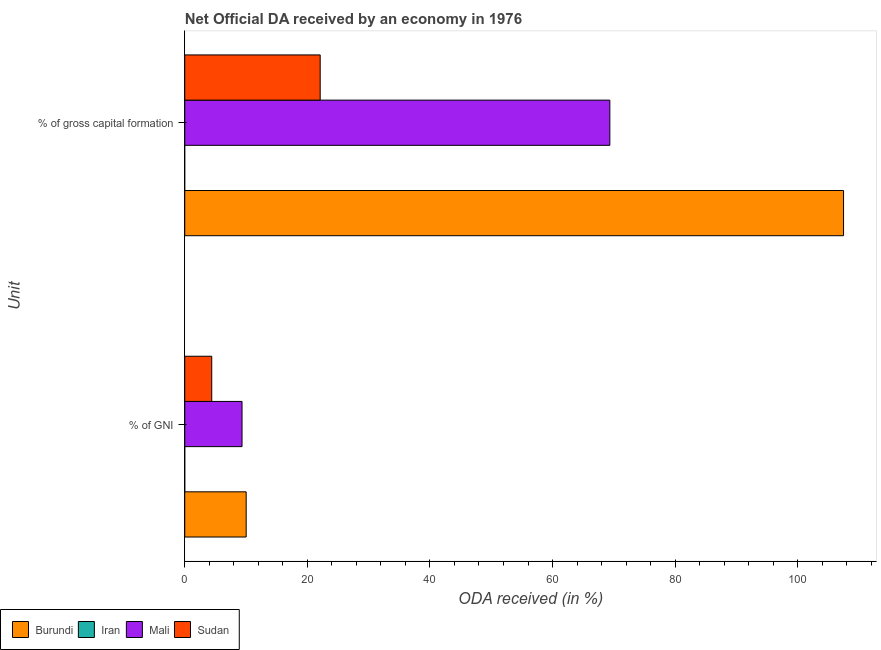How many different coloured bars are there?
Your response must be concise. 3. Are the number of bars on each tick of the Y-axis equal?
Offer a very short reply. Yes. How many bars are there on the 2nd tick from the top?
Offer a terse response. 3. What is the label of the 1st group of bars from the top?
Offer a very short reply. % of gross capital formation. What is the oda received as percentage of gni in Mali?
Your answer should be very brief. 9.35. Across all countries, what is the maximum oda received as percentage of gross capital formation?
Keep it short and to the point. 107.48. In which country was the oda received as percentage of gross capital formation maximum?
Keep it short and to the point. Burundi. What is the total oda received as percentage of gross capital formation in the graph?
Your answer should be compact. 198.92. What is the difference between the oda received as percentage of gross capital formation in Sudan and that in Mali?
Your answer should be very brief. -47.25. What is the difference between the oda received as percentage of gni in Sudan and the oda received as percentage of gross capital formation in Mali?
Keep it short and to the point. -64.95. What is the average oda received as percentage of gross capital formation per country?
Provide a succinct answer. 49.73. What is the difference between the oda received as percentage of gross capital formation and oda received as percentage of gni in Burundi?
Your answer should be compact. 97.46. In how many countries, is the oda received as percentage of gni greater than 96 %?
Give a very brief answer. 0. What is the ratio of the oda received as percentage of gross capital formation in Burundi to that in Sudan?
Your response must be concise. 4.86. How many bars are there?
Ensure brevity in your answer.  6. Are all the bars in the graph horizontal?
Provide a short and direct response. Yes. How many countries are there in the graph?
Provide a succinct answer. 4. Does the graph contain grids?
Keep it short and to the point. No. What is the title of the graph?
Keep it short and to the point. Net Official DA received by an economy in 1976. What is the label or title of the X-axis?
Your answer should be very brief. ODA received (in %). What is the label or title of the Y-axis?
Provide a short and direct response. Unit. What is the ODA received (in %) of Burundi in % of GNI?
Ensure brevity in your answer.  10.02. What is the ODA received (in %) in Mali in % of GNI?
Ensure brevity in your answer.  9.35. What is the ODA received (in %) in Sudan in % of GNI?
Offer a terse response. 4.4. What is the ODA received (in %) in Burundi in % of gross capital formation?
Offer a very short reply. 107.48. What is the ODA received (in %) of Mali in % of gross capital formation?
Provide a succinct answer. 69.35. What is the ODA received (in %) of Sudan in % of gross capital formation?
Your response must be concise. 22.1. Across all Unit, what is the maximum ODA received (in %) of Burundi?
Make the answer very short. 107.48. Across all Unit, what is the maximum ODA received (in %) of Mali?
Provide a succinct answer. 69.35. Across all Unit, what is the maximum ODA received (in %) of Sudan?
Offer a very short reply. 22.1. Across all Unit, what is the minimum ODA received (in %) of Burundi?
Give a very brief answer. 10.02. Across all Unit, what is the minimum ODA received (in %) in Mali?
Give a very brief answer. 9.35. Across all Unit, what is the minimum ODA received (in %) in Sudan?
Your answer should be very brief. 4.4. What is the total ODA received (in %) in Burundi in the graph?
Give a very brief answer. 117.49. What is the total ODA received (in %) in Mali in the graph?
Your answer should be very brief. 78.69. What is the total ODA received (in %) in Sudan in the graph?
Offer a very short reply. 26.5. What is the difference between the ODA received (in %) in Burundi in % of GNI and that in % of gross capital formation?
Offer a very short reply. -97.46. What is the difference between the ODA received (in %) in Mali in % of GNI and that in % of gross capital formation?
Offer a terse response. -60. What is the difference between the ODA received (in %) in Sudan in % of GNI and that in % of gross capital formation?
Give a very brief answer. -17.69. What is the difference between the ODA received (in %) of Burundi in % of GNI and the ODA received (in %) of Mali in % of gross capital formation?
Offer a very short reply. -59.33. What is the difference between the ODA received (in %) in Burundi in % of GNI and the ODA received (in %) in Sudan in % of gross capital formation?
Offer a terse response. -12.08. What is the difference between the ODA received (in %) of Mali in % of GNI and the ODA received (in %) of Sudan in % of gross capital formation?
Offer a very short reply. -12.75. What is the average ODA received (in %) in Burundi per Unit?
Provide a short and direct response. 58.75. What is the average ODA received (in %) of Mali per Unit?
Offer a terse response. 39.35. What is the average ODA received (in %) in Sudan per Unit?
Provide a succinct answer. 13.25. What is the difference between the ODA received (in %) in Burundi and ODA received (in %) in Mali in % of GNI?
Make the answer very short. 0.67. What is the difference between the ODA received (in %) of Burundi and ODA received (in %) of Sudan in % of GNI?
Offer a very short reply. 5.62. What is the difference between the ODA received (in %) of Mali and ODA received (in %) of Sudan in % of GNI?
Provide a succinct answer. 4.94. What is the difference between the ODA received (in %) of Burundi and ODA received (in %) of Mali in % of gross capital formation?
Ensure brevity in your answer.  38.13. What is the difference between the ODA received (in %) in Burundi and ODA received (in %) in Sudan in % of gross capital formation?
Your answer should be compact. 85.38. What is the difference between the ODA received (in %) of Mali and ODA received (in %) of Sudan in % of gross capital formation?
Provide a short and direct response. 47.25. What is the ratio of the ODA received (in %) in Burundi in % of GNI to that in % of gross capital formation?
Give a very brief answer. 0.09. What is the ratio of the ODA received (in %) in Mali in % of GNI to that in % of gross capital formation?
Ensure brevity in your answer.  0.13. What is the ratio of the ODA received (in %) of Sudan in % of GNI to that in % of gross capital formation?
Give a very brief answer. 0.2. What is the difference between the highest and the second highest ODA received (in %) in Burundi?
Your response must be concise. 97.46. What is the difference between the highest and the second highest ODA received (in %) in Mali?
Your answer should be compact. 60. What is the difference between the highest and the second highest ODA received (in %) of Sudan?
Make the answer very short. 17.69. What is the difference between the highest and the lowest ODA received (in %) in Burundi?
Your answer should be compact. 97.46. What is the difference between the highest and the lowest ODA received (in %) of Mali?
Your answer should be compact. 60. What is the difference between the highest and the lowest ODA received (in %) in Sudan?
Offer a terse response. 17.69. 